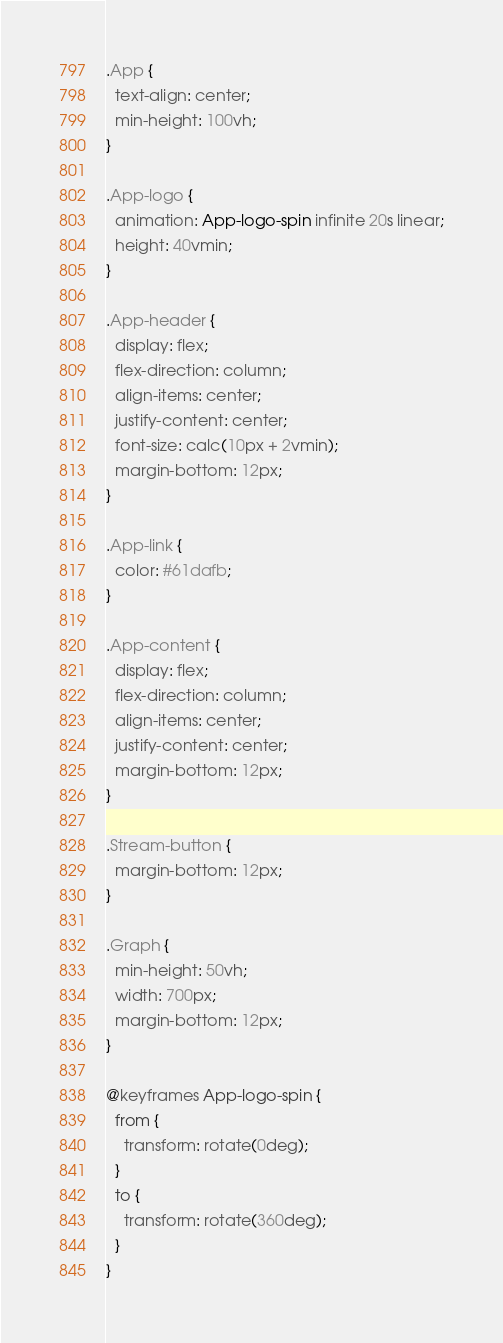Convert code to text. <code><loc_0><loc_0><loc_500><loc_500><_CSS_>.App {
  text-align: center;
  min-height: 100vh;
}

.App-logo {
  animation: App-logo-spin infinite 20s linear;
  height: 40vmin;
}

.App-header {
  display: flex;
  flex-direction: column;
  align-items: center;
  justify-content: center;
  font-size: calc(10px + 2vmin);
  margin-bottom: 12px;
}

.App-link {
  color: #61dafb;
}

.App-content {
  display: flex;
  flex-direction: column;
  align-items: center;
  justify-content: center;
  margin-bottom: 12px;
}

.Stream-button {
  margin-bottom: 12px;
}

.Graph {
  min-height: 50vh;
  width: 700px;
  margin-bottom: 12px;
}

@keyframes App-logo-spin {
  from {
    transform: rotate(0deg);
  }
  to {
    transform: rotate(360deg);
  }
}
</code> 